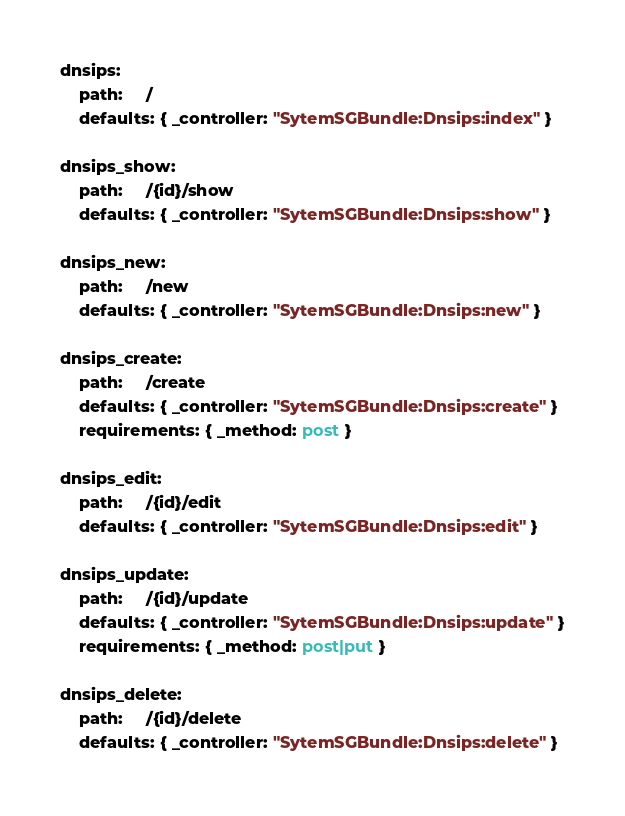Convert code to text. <code><loc_0><loc_0><loc_500><loc_500><_YAML_>dnsips:
    path:     /
    defaults: { _controller: "SytemSGBundle:Dnsips:index" }

dnsips_show:
    path:     /{id}/show
    defaults: { _controller: "SytemSGBundle:Dnsips:show" }

dnsips_new:
    path:     /new
    defaults: { _controller: "SytemSGBundle:Dnsips:new" }

dnsips_create:
    path:     /create
    defaults: { _controller: "SytemSGBundle:Dnsips:create" }
    requirements: { _method: post }

dnsips_edit:
    path:     /{id}/edit
    defaults: { _controller: "SytemSGBundle:Dnsips:edit" }

dnsips_update:
    path:     /{id}/update
    defaults: { _controller: "SytemSGBundle:Dnsips:update" }
    requirements: { _method: post|put }

dnsips_delete:
    path:     /{id}/delete
    defaults: { _controller: "SytemSGBundle:Dnsips:delete" }</code> 